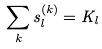<formula> <loc_0><loc_0><loc_500><loc_500>\sum _ { k } s _ { l } ^ { ( k ) } = K _ { l }</formula> 